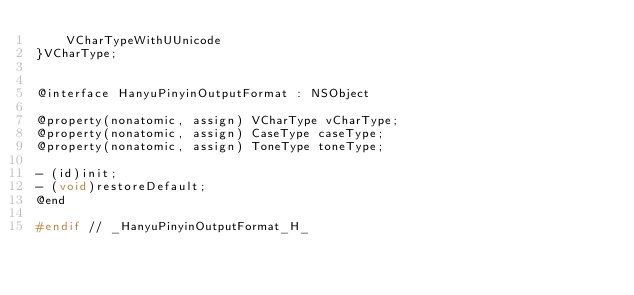Convert code to text. <code><loc_0><loc_0><loc_500><loc_500><_C_>    VCharTypeWithUUnicode
}VCharType;


@interface HanyuPinyinOutputFormat : NSObject

@property(nonatomic, assign) VCharType vCharType;
@property(nonatomic, assign) CaseType caseType;
@property(nonatomic, assign) ToneType toneType;

- (id)init;
- (void)restoreDefault;
@end

#endif // _HanyuPinyinOutputFormat_H_
</code> 